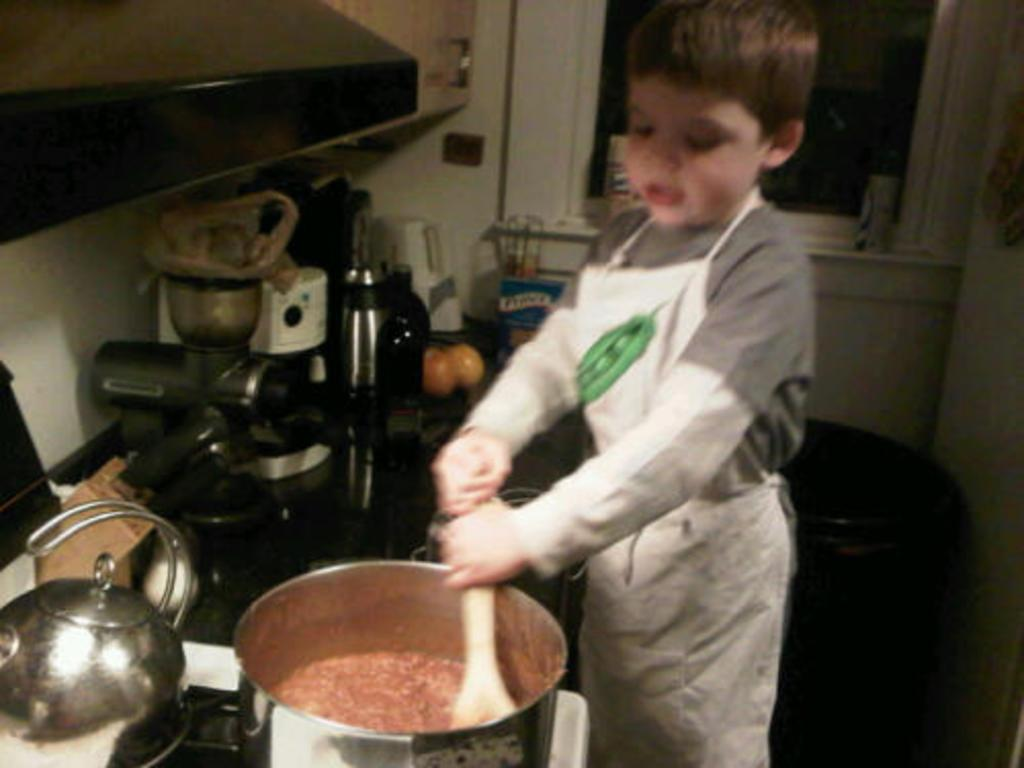Who is the main subject in the image? There is a little boy in the image. What is the boy doing in the image? The boy is standing and stirring in a bowl. Where is the boy located in the image? The setting appears to be a kitchen room. What type of square desk can be seen in the image? There is no square desk present in the image; it features a little boy standing and stirring in a bowl in a kitchen room. 